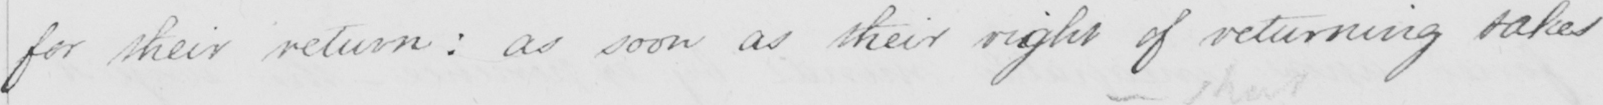Transcribe the text shown in this historical manuscript line. for their return :  as soon as their right of returning takes 